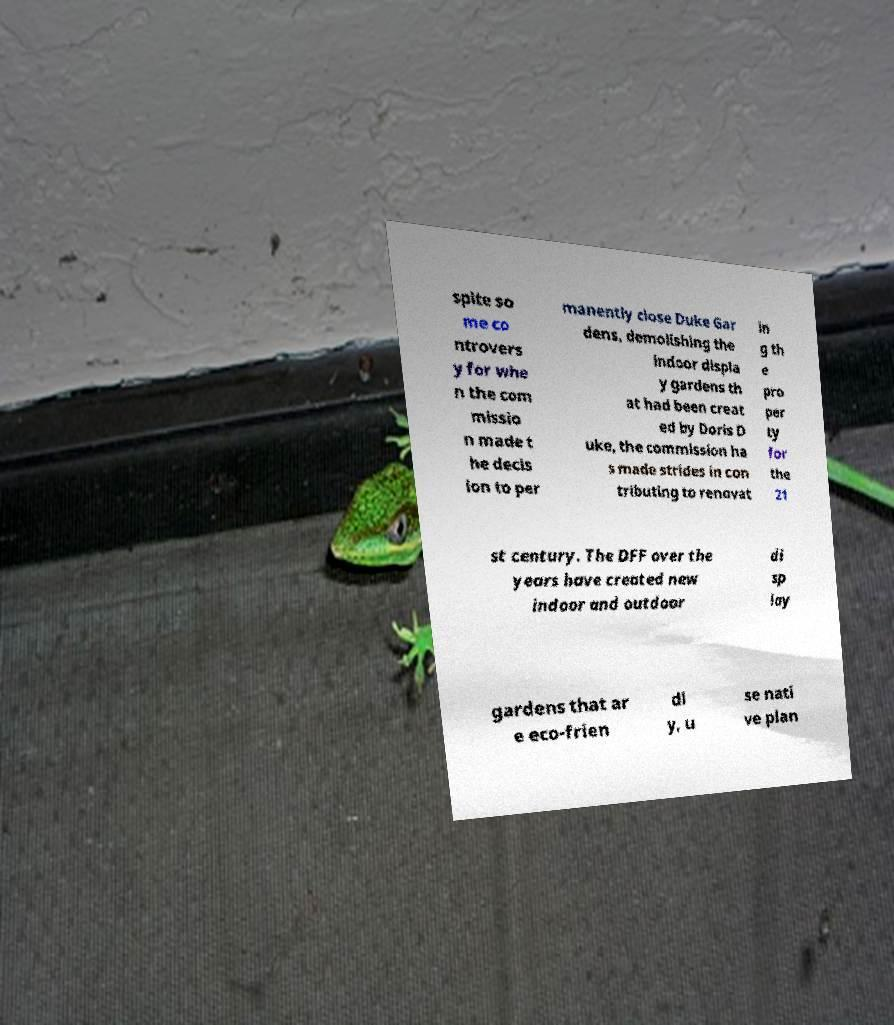Can you read and provide the text displayed in the image?This photo seems to have some interesting text. Can you extract and type it out for me? spite so me co ntrovers y for whe n the com missio n made t he decis ion to per manently close Duke Gar dens, demolishing the indoor displa y gardens th at had been creat ed by Doris D uke, the commission ha s made strides in con tributing to renovat in g th e pro per ty for the 21 st century. The DFF over the years have created new indoor and outdoor di sp lay gardens that ar e eco-frien dl y, u se nati ve plan 